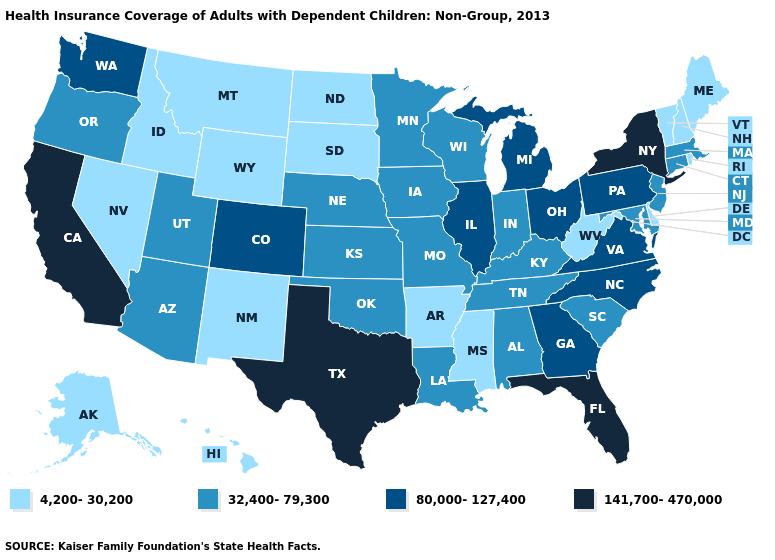Among the states that border Oklahoma , which have the lowest value?
Be succinct. Arkansas, New Mexico. Which states hav the highest value in the MidWest?
Short answer required. Illinois, Michigan, Ohio. What is the lowest value in states that border Kansas?
Give a very brief answer. 32,400-79,300. Name the states that have a value in the range 141,700-470,000?
Be succinct. California, Florida, New York, Texas. What is the value of Idaho?
Answer briefly. 4,200-30,200. Which states hav the highest value in the Northeast?
Write a very short answer. New York. What is the value of North Dakota?
Give a very brief answer. 4,200-30,200. Does the map have missing data?
Answer briefly. No. Name the states that have a value in the range 32,400-79,300?
Keep it brief. Alabama, Arizona, Connecticut, Indiana, Iowa, Kansas, Kentucky, Louisiana, Maryland, Massachusetts, Minnesota, Missouri, Nebraska, New Jersey, Oklahoma, Oregon, South Carolina, Tennessee, Utah, Wisconsin. Which states hav the highest value in the West?
Write a very short answer. California. Among the states that border Colorado , which have the highest value?
Answer briefly. Arizona, Kansas, Nebraska, Oklahoma, Utah. Which states have the lowest value in the USA?
Be succinct. Alaska, Arkansas, Delaware, Hawaii, Idaho, Maine, Mississippi, Montana, Nevada, New Hampshire, New Mexico, North Dakota, Rhode Island, South Dakota, Vermont, West Virginia, Wyoming. What is the value of Virginia?
Answer briefly. 80,000-127,400. How many symbols are there in the legend?
Be succinct. 4. Does Minnesota have a higher value than Massachusetts?
Be succinct. No. 